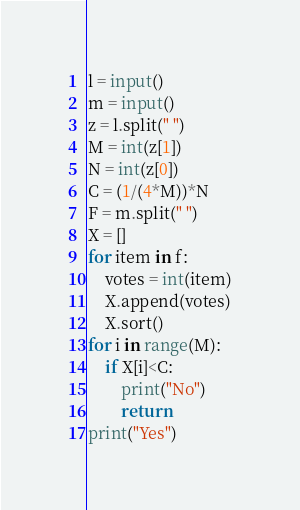Convert code to text. <code><loc_0><loc_0><loc_500><loc_500><_Python_>l = input()
m = input()
z = l.split(" ")
M = int(z[1])
N = int(z[0])
C = (1/(4*M))*N
F = m.split(" ")
X = []
for item in f:
	votes = int(item)
	X.append(votes)
	X.sort()
for i in range(M):
	if X[i]<C:
		print("No")
		return
print("Yes")
</code> 